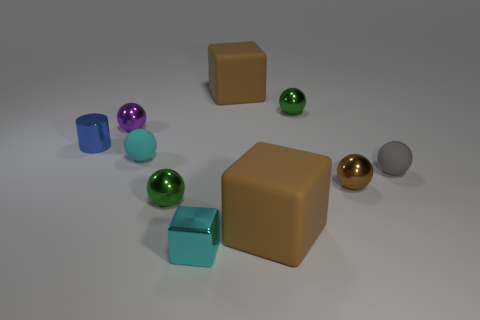What number of other things are the same color as the small block?
Offer a terse response. 1. Do the metal cylinder and the big matte object in front of the purple metal thing have the same color?
Ensure brevity in your answer.  No. There is a ball that is both in front of the small gray sphere and left of the tiny brown thing; what is its material?
Your answer should be very brief. Metal. Is the shape of the green metallic thing behind the small purple shiny thing the same as the small green object that is in front of the purple sphere?
Ensure brevity in your answer.  Yes. Is there a shiny cylinder?
Offer a terse response. Yes. The other small rubber object that is the same shape as the gray object is what color?
Offer a terse response. Cyan. There is a matte ball that is the same size as the gray rubber object; what color is it?
Offer a very short reply. Cyan. Does the blue object have the same material as the small brown ball?
Give a very brief answer. Yes. How many other tiny shiny cubes have the same color as the metallic block?
Offer a very short reply. 0. There is a big block that is in front of the tiny blue cylinder; what material is it?
Provide a succinct answer. Rubber. 